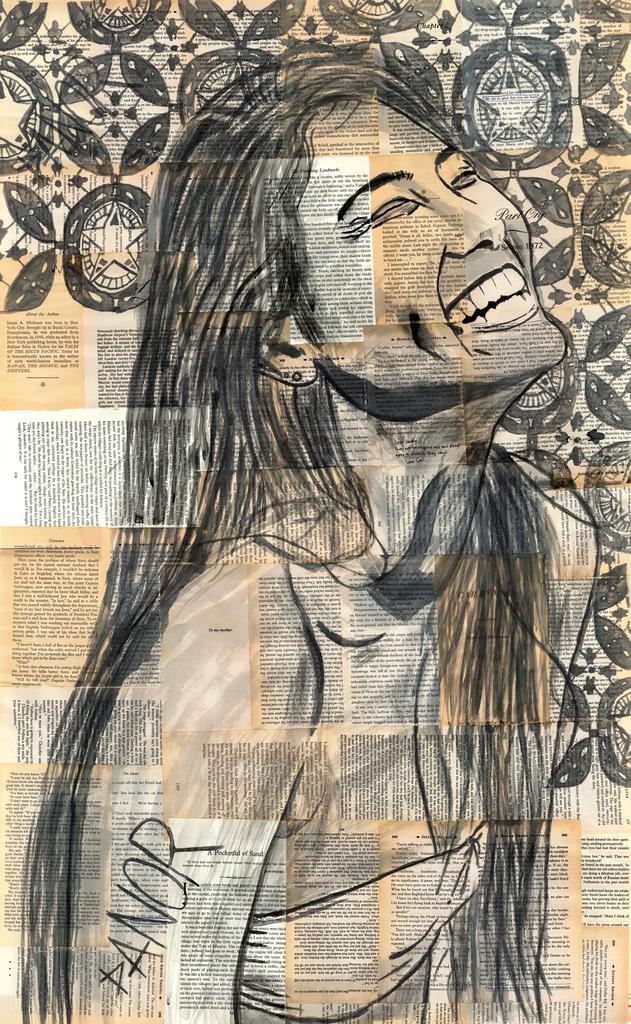Who is the artist for this piece?
Keep it short and to the point. Danor. 